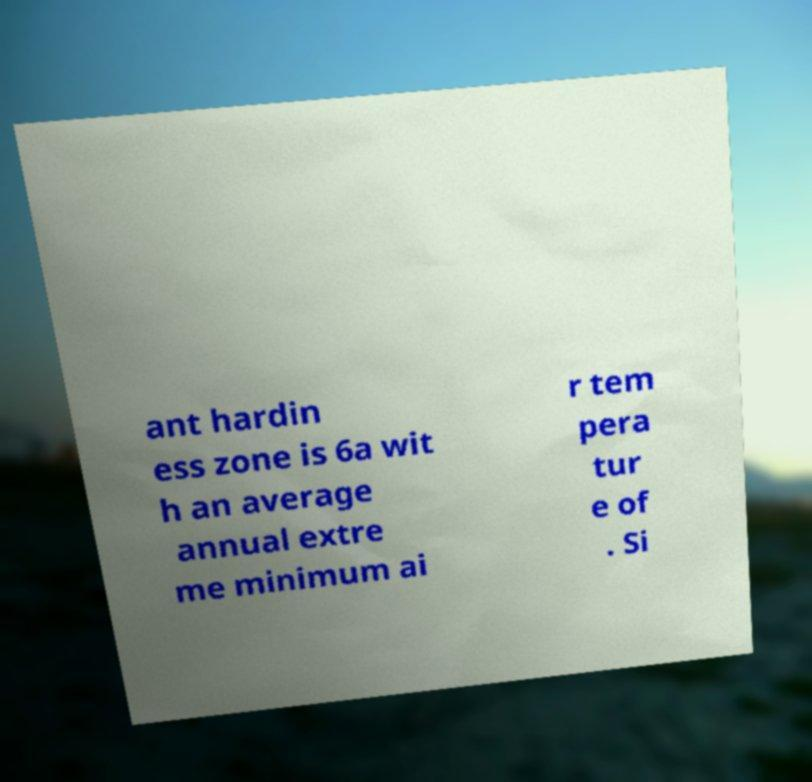Please read and relay the text visible in this image. What does it say? ant hardin ess zone is 6a wit h an average annual extre me minimum ai r tem pera tur e of . Si 